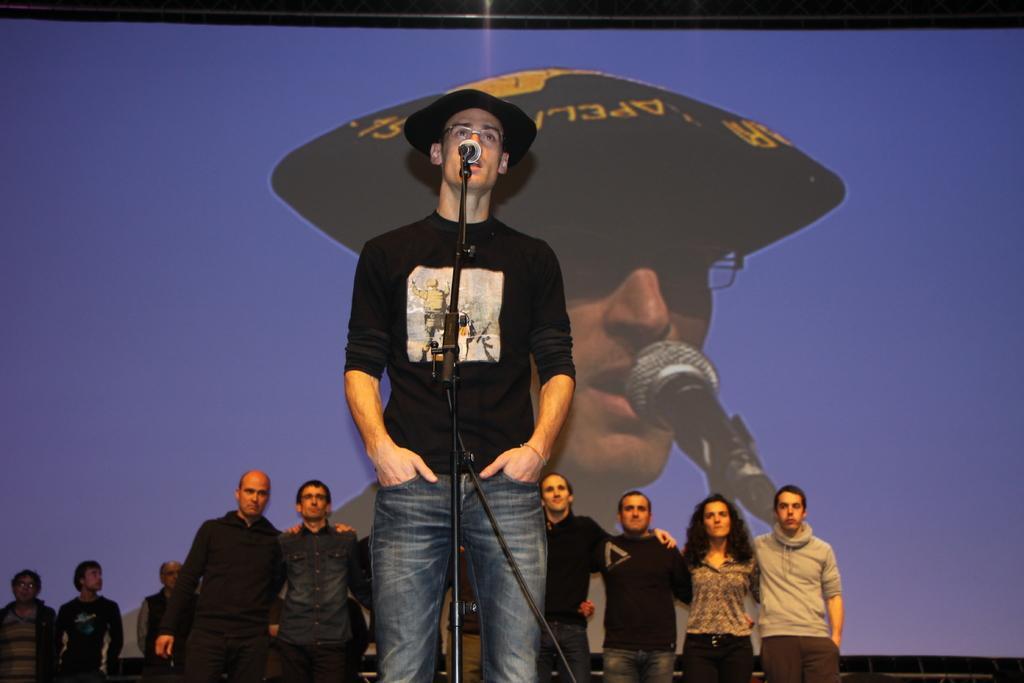Could you give a brief overview of what you see in this image? In the middle of this image, there is a person in a black color t-shirt, wearing a cap, standing and speaking in front of a mic, which is attached to a stand. In the background, there are other persons standing and there is a screen arranged. 